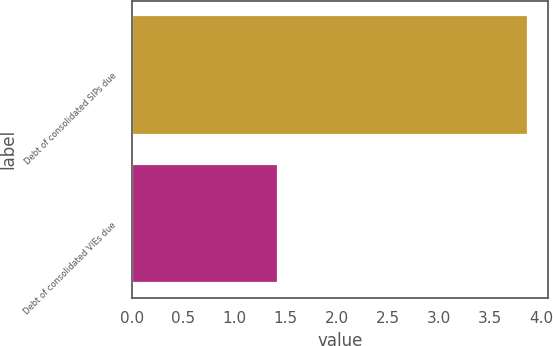Convert chart to OTSL. <chart><loc_0><loc_0><loc_500><loc_500><bar_chart><fcel>Debt of consolidated SIPs due<fcel>Debt of consolidated VIEs due<nl><fcel>3.87<fcel>1.43<nl></chart> 